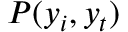<formula> <loc_0><loc_0><loc_500><loc_500>P ( y _ { i } , y _ { t } )</formula> 